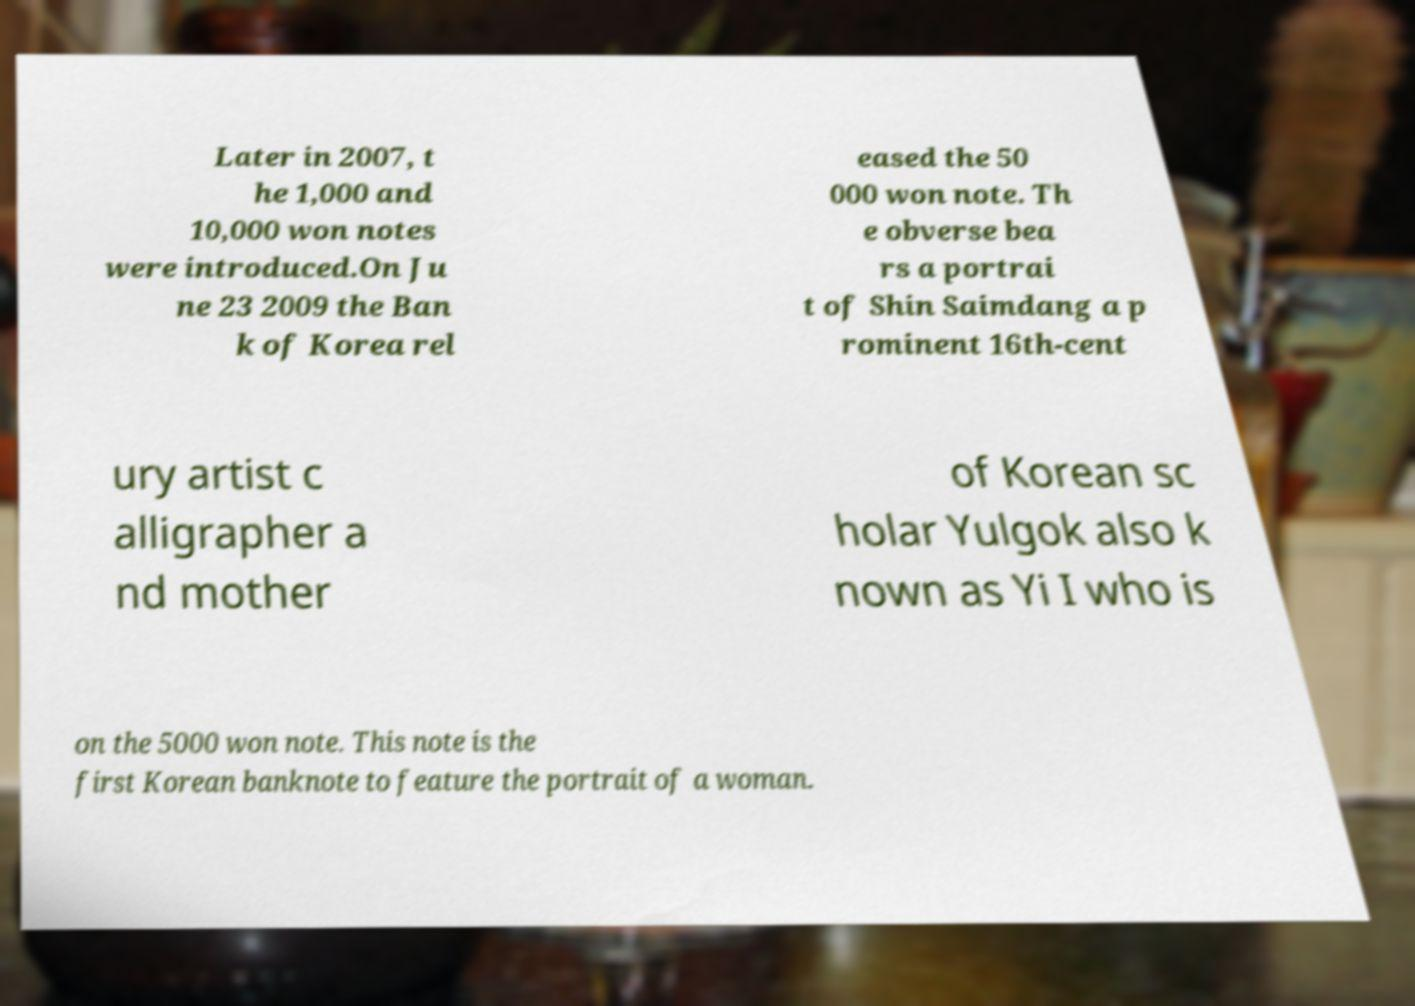Could you extract and type out the text from this image? Later in 2007, t he 1,000 and 10,000 won notes were introduced.On Ju ne 23 2009 the Ban k of Korea rel eased the 50 000 won note. Th e obverse bea rs a portrai t of Shin Saimdang a p rominent 16th-cent ury artist c alligrapher a nd mother of Korean sc holar Yulgok also k nown as Yi I who is on the 5000 won note. This note is the first Korean banknote to feature the portrait of a woman. 